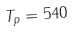Convert formula to latex. <formula><loc_0><loc_0><loc_500><loc_500>T _ { p } = 5 4 0</formula> 